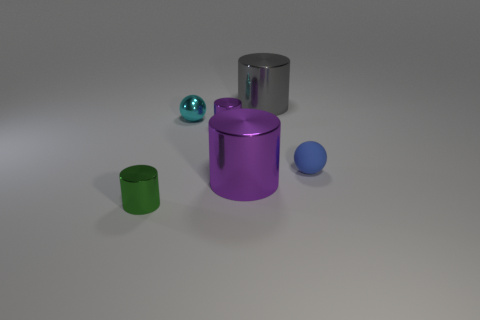Subtract all tiny green metallic cylinders. How many cylinders are left? 3 Subtract 3 cylinders. How many cylinders are left? 1 Add 1 big metal cylinders. How many objects exist? 7 Subtract all green cylinders. How many cylinders are left? 3 Subtract 0 red cylinders. How many objects are left? 6 Subtract all balls. How many objects are left? 4 Subtract all blue balls. Subtract all blue cylinders. How many balls are left? 1 Subtract all yellow spheres. How many yellow cylinders are left? 0 Subtract all large metal cylinders. Subtract all tiny gray metallic things. How many objects are left? 4 Add 6 small metal cylinders. How many small metal cylinders are left? 8 